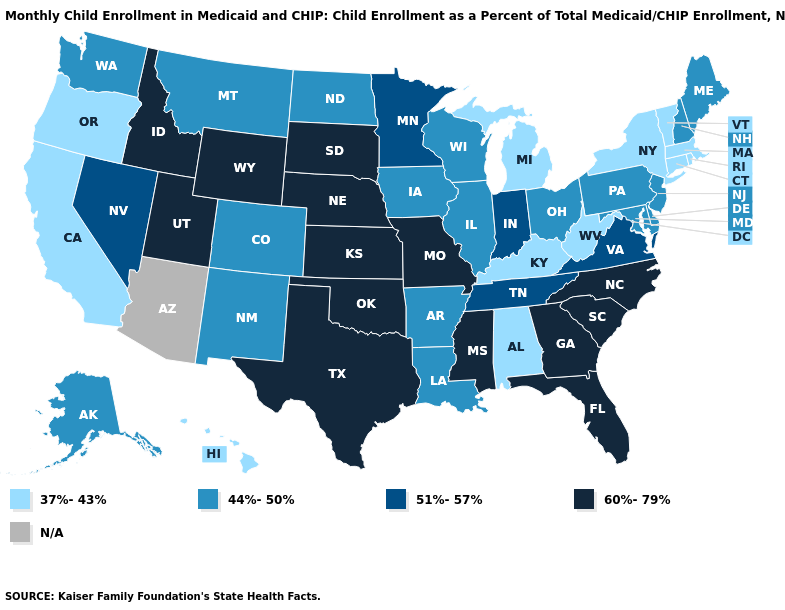What is the value of Idaho?
Keep it brief. 60%-79%. Among the states that border North Carolina , does Tennessee have the highest value?
Short answer required. No. Name the states that have a value in the range 37%-43%?
Quick response, please. Alabama, California, Connecticut, Hawaii, Kentucky, Massachusetts, Michigan, New York, Oregon, Rhode Island, Vermont, West Virginia. What is the value of Maine?
Answer briefly. 44%-50%. What is the highest value in the MidWest ?
Answer briefly. 60%-79%. Name the states that have a value in the range N/A?
Short answer required. Arizona. What is the value of Maine?
Give a very brief answer. 44%-50%. Name the states that have a value in the range 51%-57%?
Answer briefly. Indiana, Minnesota, Nevada, Tennessee, Virginia. Which states have the highest value in the USA?
Be succinct. Florida, Georgia, Idaho, Kansas, Mississippi, Missouri, Nebraska, North Carolina, Oklahoma, South Carolina, South Dakota, Texas, Utah, Wyoming. Name the states that have a value in the range 51%-57%?
Concise answer only. Indiana, Minnesota, Nevada, Tennessee, Virginia. Which states have the highest value in the USA?
Keep it brief. Florida, Georgia, Idaho, Kansas, Mississippi, Missouri, Nebraska, North Carolina, Oklahoma, South Carolina, South Dakota, Texas, Utah, Wyoming. What is the highest value in the USA?
Be succinct. 60%-79%. Name the states that have a value in the range 37%-43%?
Concise answer only. Alabama, California, Connecticut, Hawaii, Kentucky, Massachusetts, Michigan, New York, Oregon, Rhode Island, Vermont, West Virginia. Does South Carolina have the highest value in the South?
Be succinct. Yes. 